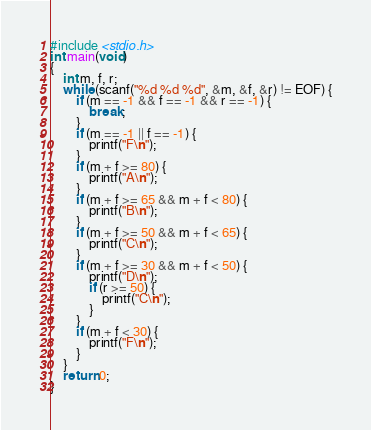<code> <loc_0><loc_0><loc_500><loc_500><_C_>#include <stdio.h>
int main(void) 
{
	int m, f, r;
	while (scanf("%d %d %d", &m, &f, &r) != EOF) {
		if (m == -1 && f == -1 && r == -1) {
			break;
		}
		if (m == -1 || f == -1) {
			printf("F\n");
		}
		if (m + f >= 80) {
			printf("A\n");
		}
		if (m + f >= 65 && m + f < 80) {
			printf("B\n");
		}
		if (m + f >= 50 && m + f < 65) {
			printf("C\n");
		}
		if (m + f >= 30 && m + f < 50) {
			printf("D\n");
			if (r >= 50) {
				printf("C\n");
			}
		}
		if (m + f < 30) {
			printf("F\n");
		}
	}
	return 0;
}

</code> 